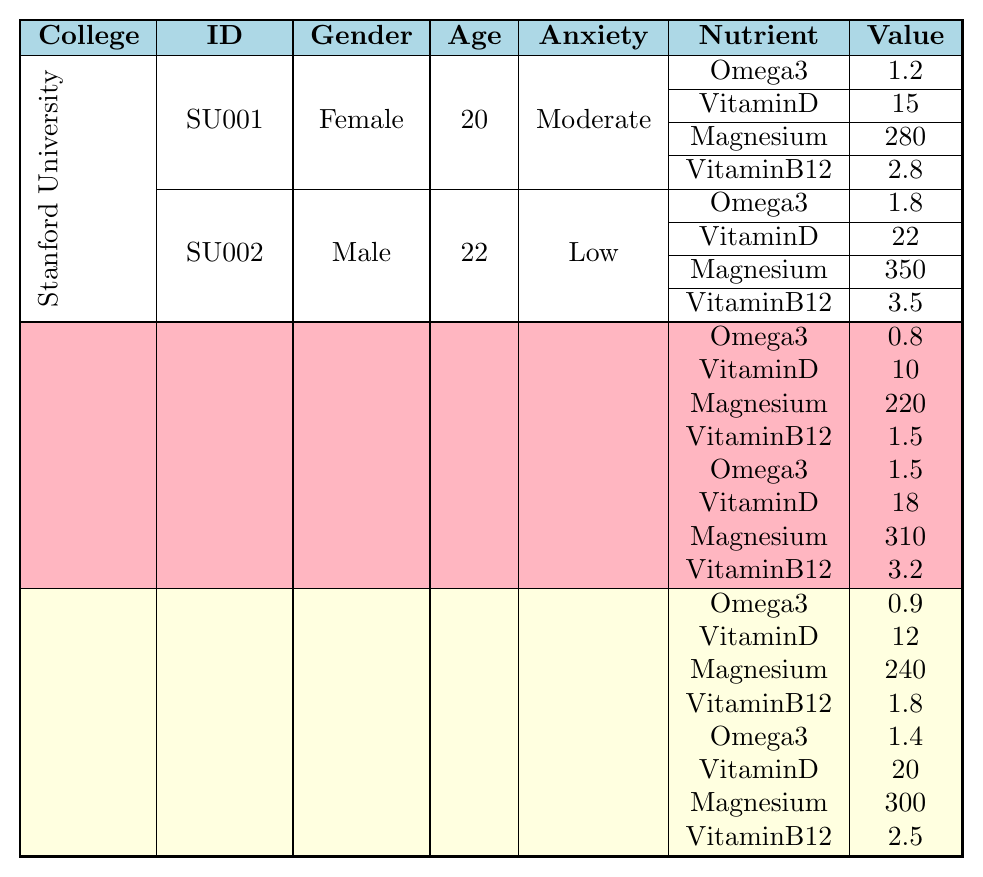What is the Omega-3 intake for the student from Stanford University with a low anxiety level? Looking at the row corresponding to the student ID "SU002," who is male and has a low anxiety level, the Omega-3 intake value is 1.8.
Answer: 1.8 What is the average Magnesium intake for all students at MIT? For MIT, the students’ Magnesium intakes are 240 (MIT001) and 300 (MIT002). Adding these values gives 240 + 300 = 540, then dividing by 2 results in an average Magnesium intake of 540/2 = 270.
Answer: 270 Is there a male student from UC Berkeley with a lower anxiety level than a female student? The male student UCB001 has a high anxiety level, while the female student UCB002 has a low anxiety level. Thus, there is no male student with a lower anxiety level than the female student from UC Berkeley.
Answer: No What is the highest Vitamin D intake among all students, and which student has it? Scanning through the Vitamin D values, the highest intake is 22, found in the male student (SU002) from Stanford University.
Answer: 22, SU002 Which college has more students with a moderate anxiety level, and how many are there? Both Stanford University (two students - SU001 is moderate, and SU002 is low) and MIT (one moderate) are assessed. Stanford has 1 student with moderate anxiety, while MIT has 1 as well. So, they tie for the same number of students with a moderate anxiety level.
Answer: Stanford and MIT, 1 each If a student eats a diet high in Vitamin B12, which college student has that, and what is their anxiety level? From the data, the student UCB002 from UC Berkeley has the highest Vitamin B12 intake of 3.2 and possesses a low anxiety level.
Answer: UCB002, Low Which nutrient intake value is the least among all students? Comparing all nutrient intake values, the lowest value is 0.8 Omega-3, which belongs to the male student UCB001 from UC Berkeley.
Answer: 0.8 What is the difference in Magnesium intake between the highest and lowest intakes in this data set? The highest Magnesium intake is 350 from SU002 (Stanford), and the lowest is 220 from UCB001 (UC Berkeley). The difference is 350 - 220 = 130.
Answer: 130 How many students from each college have high anxiety levels? In the table, UC Berkeley has 1 (UCB001) and MIT has 1 (MIT001), summing them gives a total of 2 students with high anxiety levels across both colleges.
Answer: 2 Is there a female student at Stanford who has a higher Omega-3 intake than the male student at the same college? The female student SU001 has an Omega-3 intake of 1.2, while the male student SU002 has a higher intake of 1.8. Therefore, SU001 does not have a higher Omega-3 intake than SU002.
Answer: No 